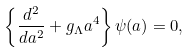<formula> <loc_0><loc_0><loc_500><loc_500>\left \{ \frac { d ^ { 2 } } { d a ^ { 2 } } + g _ { \Lambda } a ^ { 4 } \right \} \psi ( a ) = 0 ,</formula> 